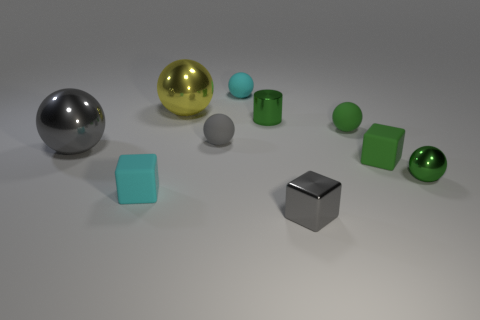How many other objects are the same color as the metal cube?
Provide a succinct answer. 2. The small rubber ball that is right of the tiny metal block is what color?
Make the answer very short. Green. Is there a shiny ball of the same size as the gray rubber sphere?
Offer a terse response. Yes. There is a gray object that is the same size as the gray matte ball; what material is it?
Your response must be concise. Metal. What number of things are gray shiny objects right of the cyan matte block or metallic objects on the left side of the small cyan ball?
Your response must be concise. 3. Are there any tiny objects that have the same shape as the large gray thing?
Provide a succinct answer. Yes. There is a cylinder that is the same color as the tiny shiny ball; what is it made of?
Provide a short and direct response. Metal. What number of metallic objects are either tiny green cylinders or yellow spheres?
Keep it short and to the point. 2. The large gray metal object has what shape?
Offer a terse response. Sphere. How many gray spheres are made of the same material as the tiny cyan cube?
Offer a terse response. 1. 